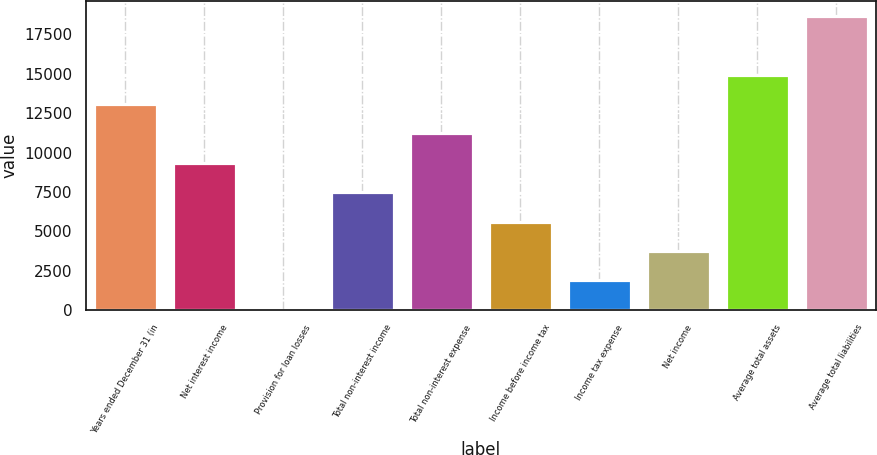Convert chart to OTSL. <chart><loc_0><loc_0><loc_500><loc_500><bar_chart><fcel>Years ended December 31 (in<fcel>Net interest income<fcel>Provision for loan losses<fcel>Total non-interest income<fcel>Total non-interest expense<fcel>Income before income tax<fcel>Income tax expense<fcel>Net income<fcel>Average total assets<fcel>Average total liabilities<nl><fcel>13078.3<fcel>9345.6<fcel>13.9<fcel>7479.26<fcel>11211.9<fcel>5612.92<fcel>1880.24<fcel>3746.58<fcel>14944.6<fcel>18677.3<nl></chart> 